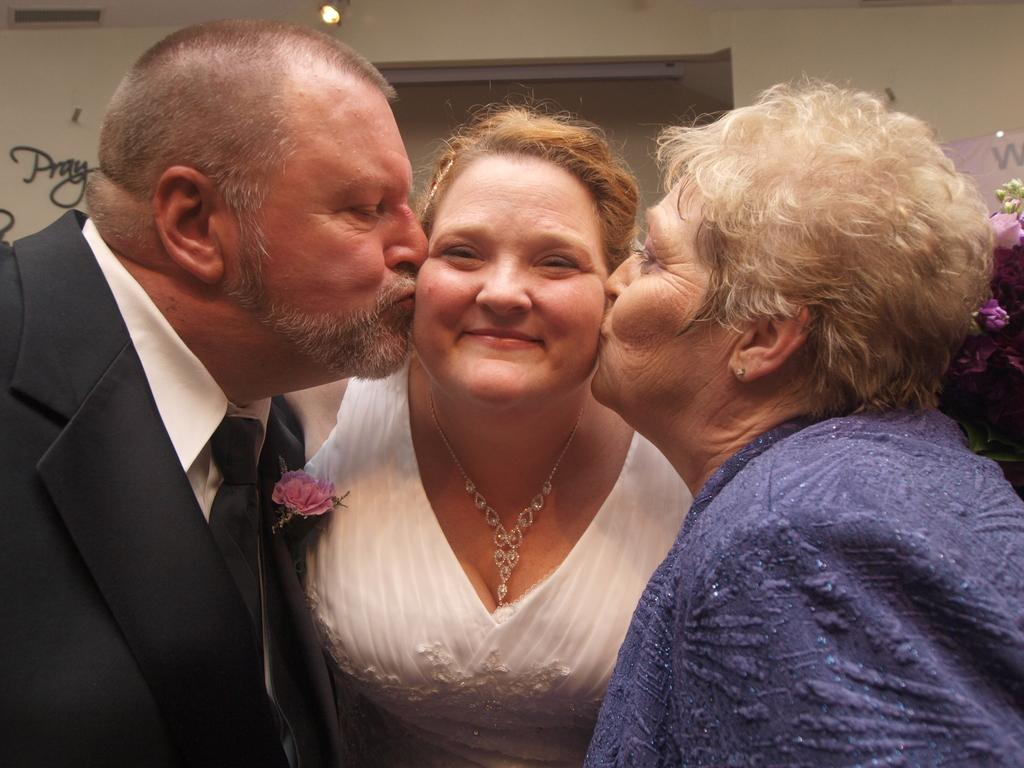How many people are present in the image? There are three people in the image. Can you describe the expression of one of the people? A woman is smiling in the image. What can be seen in the background of the image? There are flowers, a wall, a light, and some text visible in the background of the image. What type of leaf is being used as a detail in the woman's hair in the image? There is no leaf present in the image, nor is there any indication that a leaf is being used as a detail in the woman's hair. 